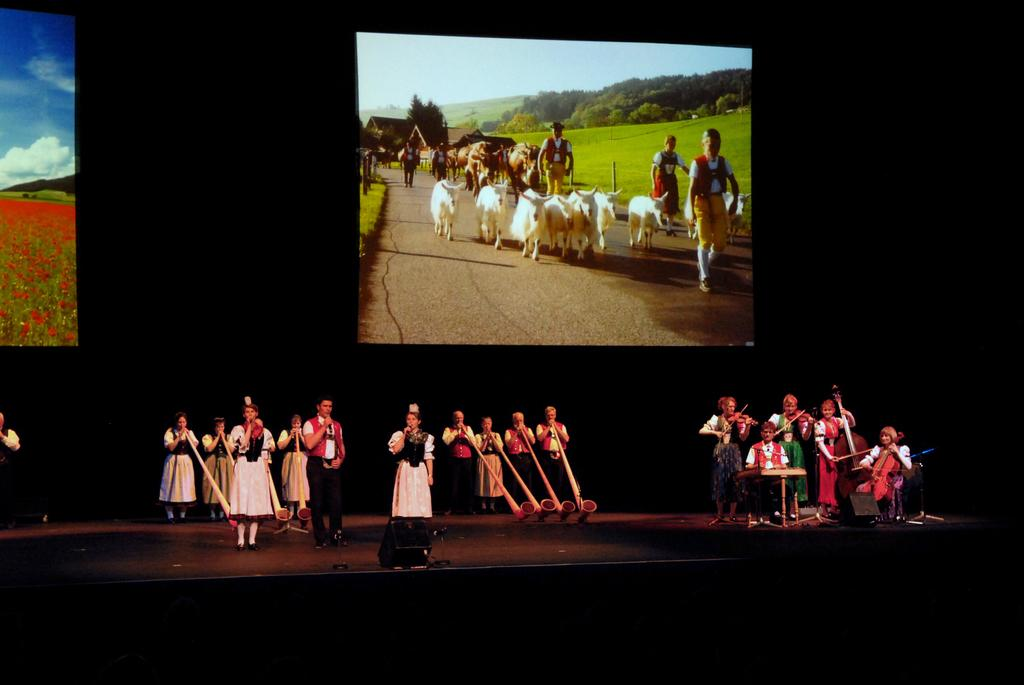What is the main subject of the image? The main subject of the image is people. Where are the people located in the image? The people are on a stage in the image. What can be seen in the background of the image? There are posters in the background of the image. What type of chin can be seen on the people in the image? There is no specific chin mentioned or visible in the image; it is not possible to answer this question based on the provided facts. 